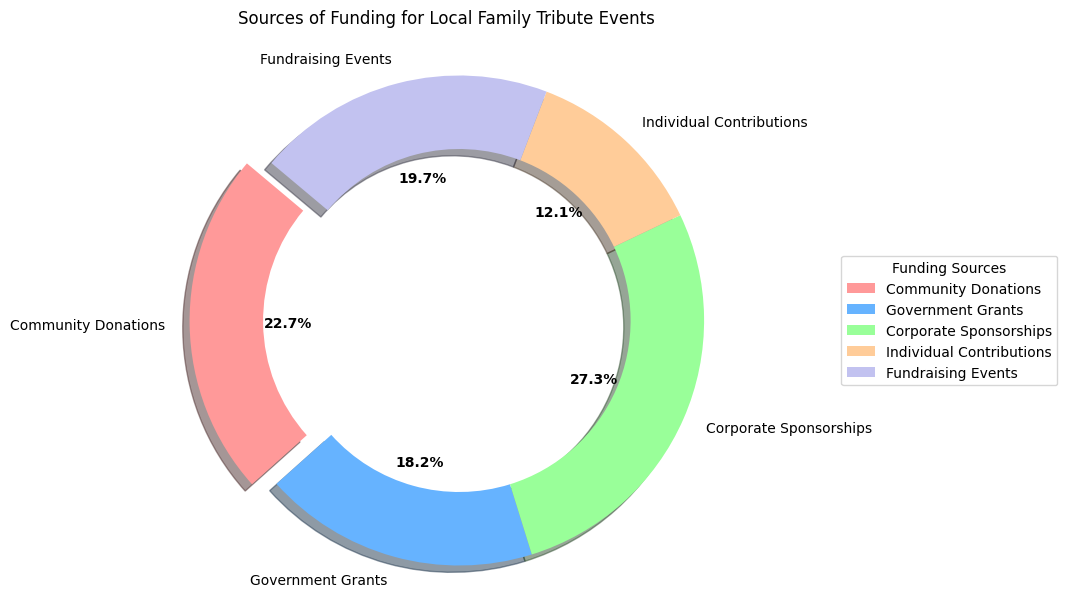What percentage of funding comes from Community Donations? Look at the "Community Donations" segment of the pie chart and the percentage label.
Answer: 31.0% Which funding source contributes the smallest percentage? Compare the percentage labels on all the segments of the pie chart to find the smallest one.
Answer: Individual Contributions What is the total amount of funding from Government Grants and Corporate Sponsorships? Sum the amounts for "Government Grants" (12000) and "Corporate Sponsorships" (18000). 12000 + 18000 = 30000
Answer: 30000 How does the amount of Corporate Sponsorships compare to Fundraising Events? Look at the segments for "Corporate Sponsorships" and "Fundraising Events" and compare the amounts. Corporate Sponsorships is 18000 and Fundraising Events is 13000. 18000 is greater than 13000.
Answer: Corporate Sponsorships is greater than Fundraising Events What color represents Individual Contributions? Identify the segment for "Individual Contributions" in the pie chart and note its color.
Answer: Orange 